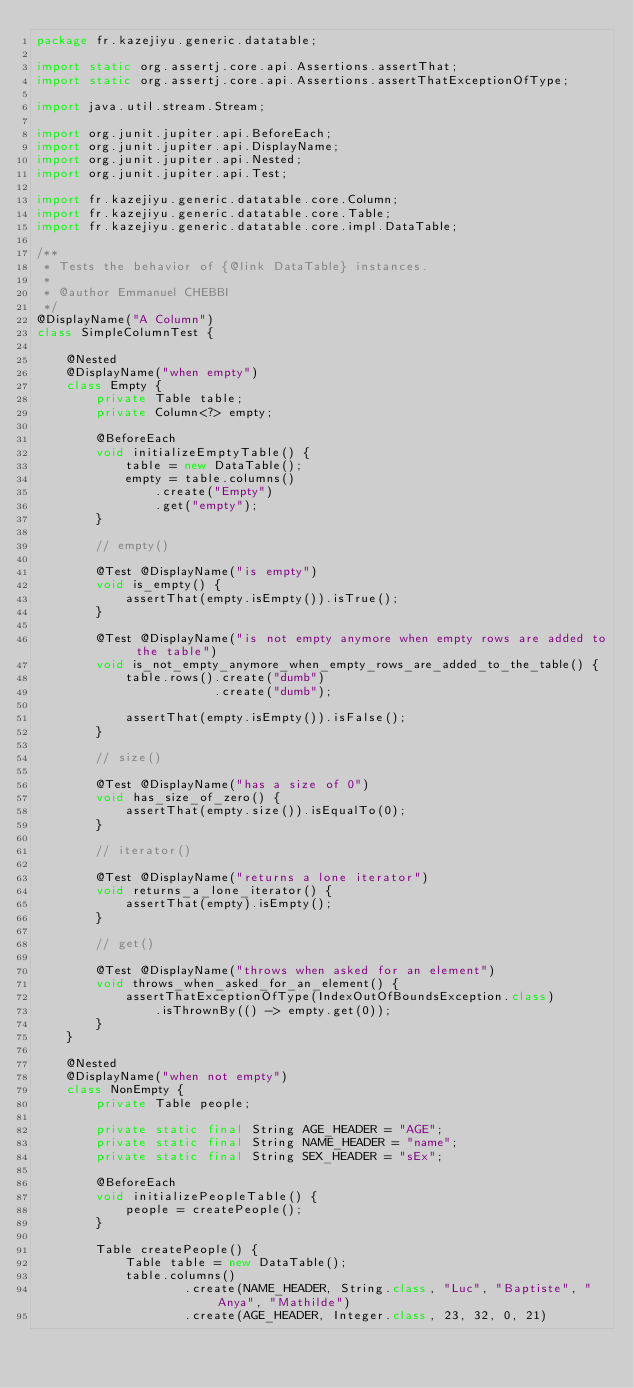Convert code to text. <code><loc_0><loc_0><loc_500><loc_500><_Java_>package fr.kazejiyu.generic.datatable;

import static org.assertj.core.api.Assertions.assertThat;
import static org.assertj.core.api.Assertions.assertThatExceptionOfType;

import java.util.stream.Stream;

import org.junit.jupiter.api.BeforeEach;
import org.junit.jupiter.api.DisplayName;
import org.junit.jupiter.api.Nested;
import org.junit.jupiter.api.Test;

import fr.kazejiyu.generic.datatable.core.Column;
import fr.kazejiyu.generic.datatable.core.Table;
import fr.kazejiyu.generic.datatable.core.impl.DataTable;

/**
 * Tests the behavior of {@link DataTable} instances.
 * 
 * @author Emmanuel CHEBBI
 */
@DisplayName("A Column")
class SimpleColumnTest {
	
	@Nested
	@DisplayName("when empty")
	class Empty {
		private Table table;
		private Column<?> empty;
		
		@BeforeEach
		void initializeEmptyTable() {
			table = new DataTable();
			empty = table.columns()
				.create("Empty")
				.get("empty");
		}
		
		// empty()
		
		@Test @DisplayName("is empty")
		void is_empty() {
			assertThat(empty.isEmpty()).isTrue();
		}
		
		@Test @DisplayName("is not empty anymore when empty rows are added to the table")
		void is_not_empty_anymore_when_empty_rows_are_added_to_the_table() {
			table.rows().create("dumb")
						.create("dumb");
			
			assertThat(empty.isEmpty()).isFalse();
		}
		
		// size()
		
		@Test @DisplayName("has a size of 0")
		void has_size_of_zero() {
			assertThat(empty.size()).isEqualTo(0);
		}
		
		// iterator()
		
		@Test @DisplayName("returns a lone iterator")
		void returns_a_lone_iterator() {
			assertThat(empty).isEmpty();
		}
		
		// get()
		
		@Test @DisplayName("throws when asked for an element") 
		void throws_when_asked_for_an_element() {
			assertThatExceptionOfType(IndexOutOfBoundsException.class)
				.isThrownBy(() -> empty.get(0));
		}
	}
	
	@Nested
	@DisplayName("when not empty")
	class NonEmpty {
		private Table people;
		
		private static final String AGE_HEADER = "AGE";
		private static final String NAME_HEADER = "name";
		private static final String SEX_HEADER = "sEx";
		
		@BeforeEach
		void initializePeopleTable() {
			people = createPeople();
		}
		
		Table createPeople() {
			Table table = new DataTable();
			table.columns()
					.create(NAME_HEADER, String.class, "Luc", "Baptiste", "Anya", "Mathilde")
					.create(AGE_HEADER, Integer.class, 23, 32, 0, 21)</code> 